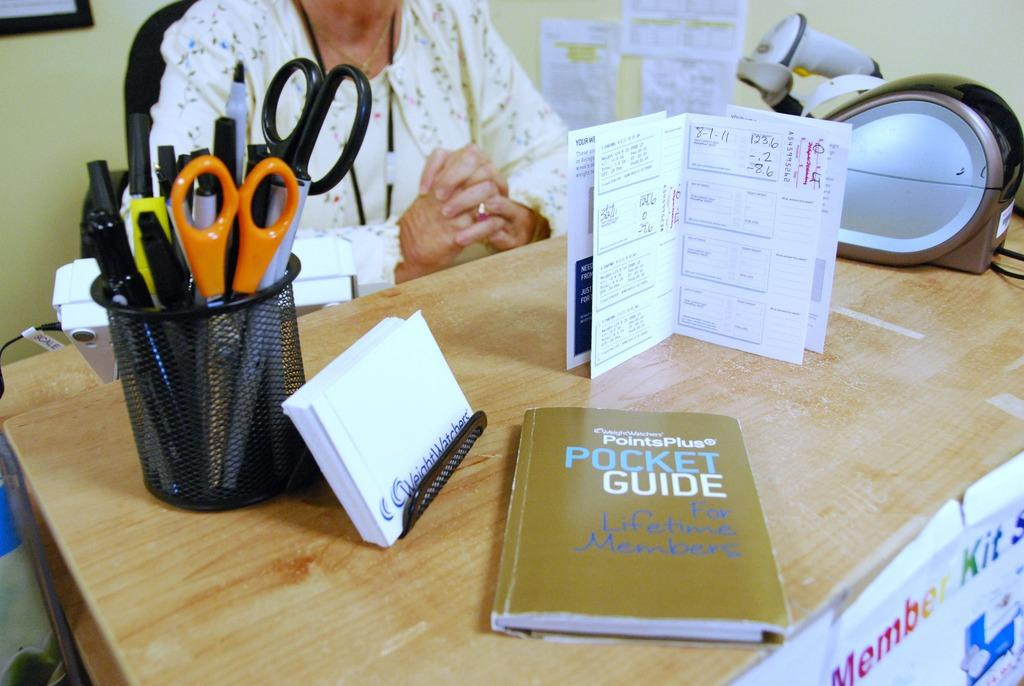Provide a one-sentence caption for the provided image. A book with the title Pocket Guide is on a desk that a person sits at. 